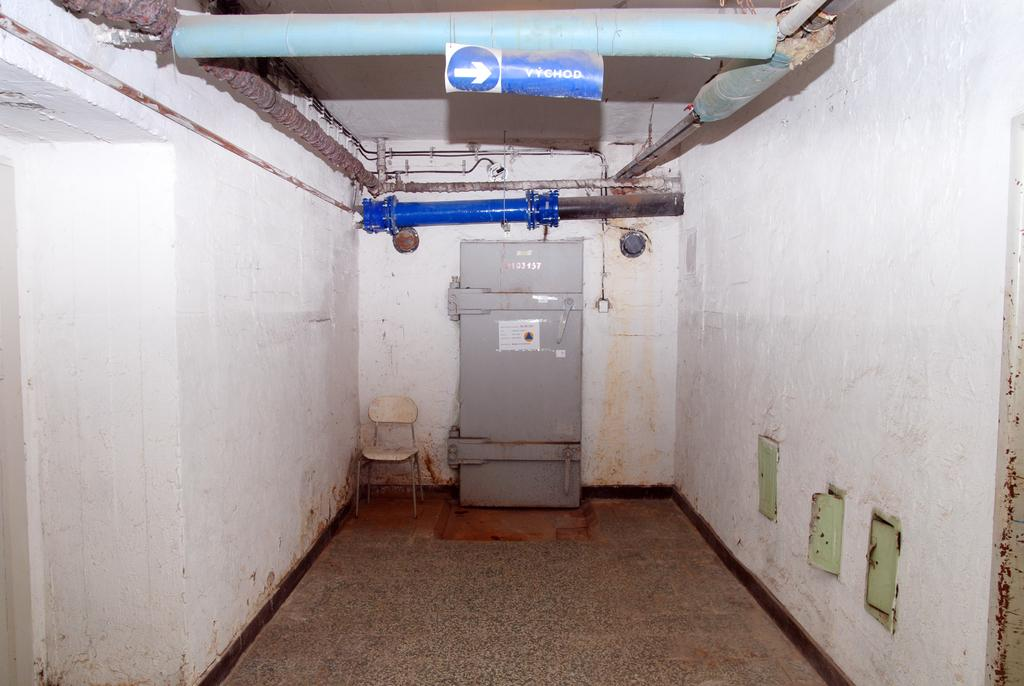Provide a one-sentence caption for the provided image. A sign hanging in a grim dirty industrial chamber reads VYCHOD. 